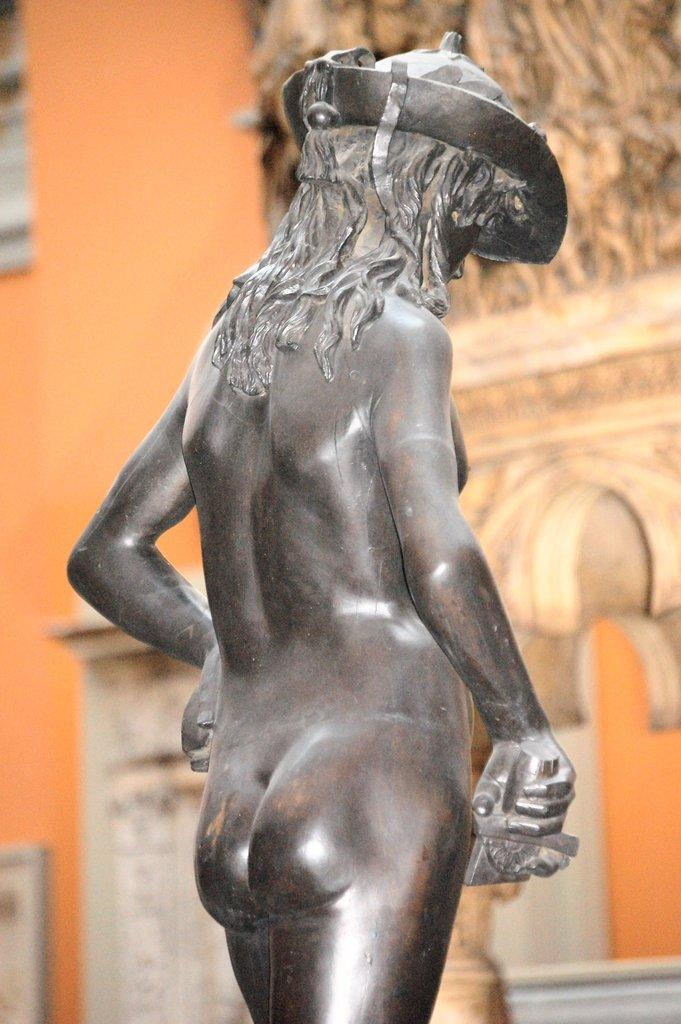What is the main subject in the image? There is a statue in the image. What can be said about the color of the statue? The statue is gray in color. How does the statue get a haircut in the image? The statue does not get a haircut in the image, as it is a non-living object made of a material like stone or metal. 